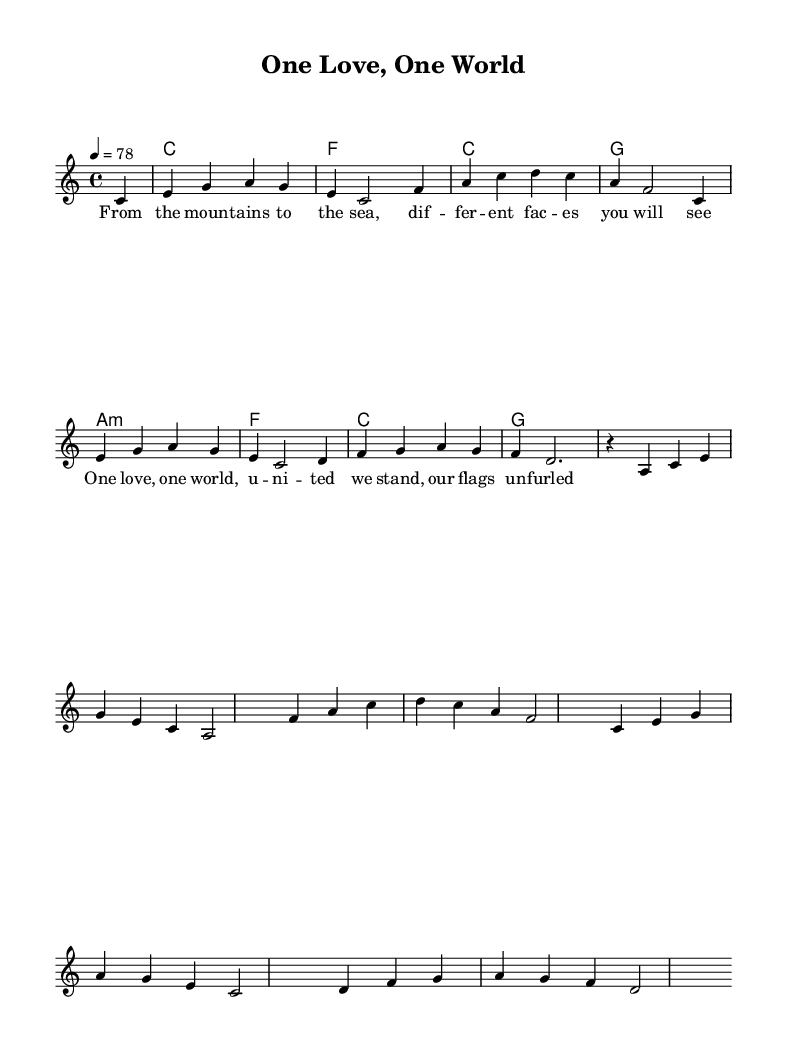What is the key signature of this music? The key signature is C major, which has no sharps or flats.
Answer: C major What is the time signature of this music? The time signature is indicated at the start of the piece, showing there are four beats in each measure.
Answer: 4/4 What is the tempo marking for this piece? The tempo marking indicates a speed of 78 beats per minute, which provides a moderate pace for the performance.
Answer: 78 How many measures are in the melody section? By counting the measures in the melody part, there are eight distinct measures before the score transitions or repeats.
Answer: 8 What type of chords are predominantly used in this piece? The chord progression is typical of reggae music, and it features major and minor chords, highlighting the joyful nature of the genre.
Answer: Major and minor What is the main theme expressed in the lyrics of this piece? The lyrics focus on the unity and diversity of people, celebrating cultural differences while promoting togetherness and peace.
Answer: Unity and diversity Which instrument is primarily featured in the score? The score is designed for a keyboard instrument, with a provided melody line that is written for a single voice.
Answer: Keyboard 